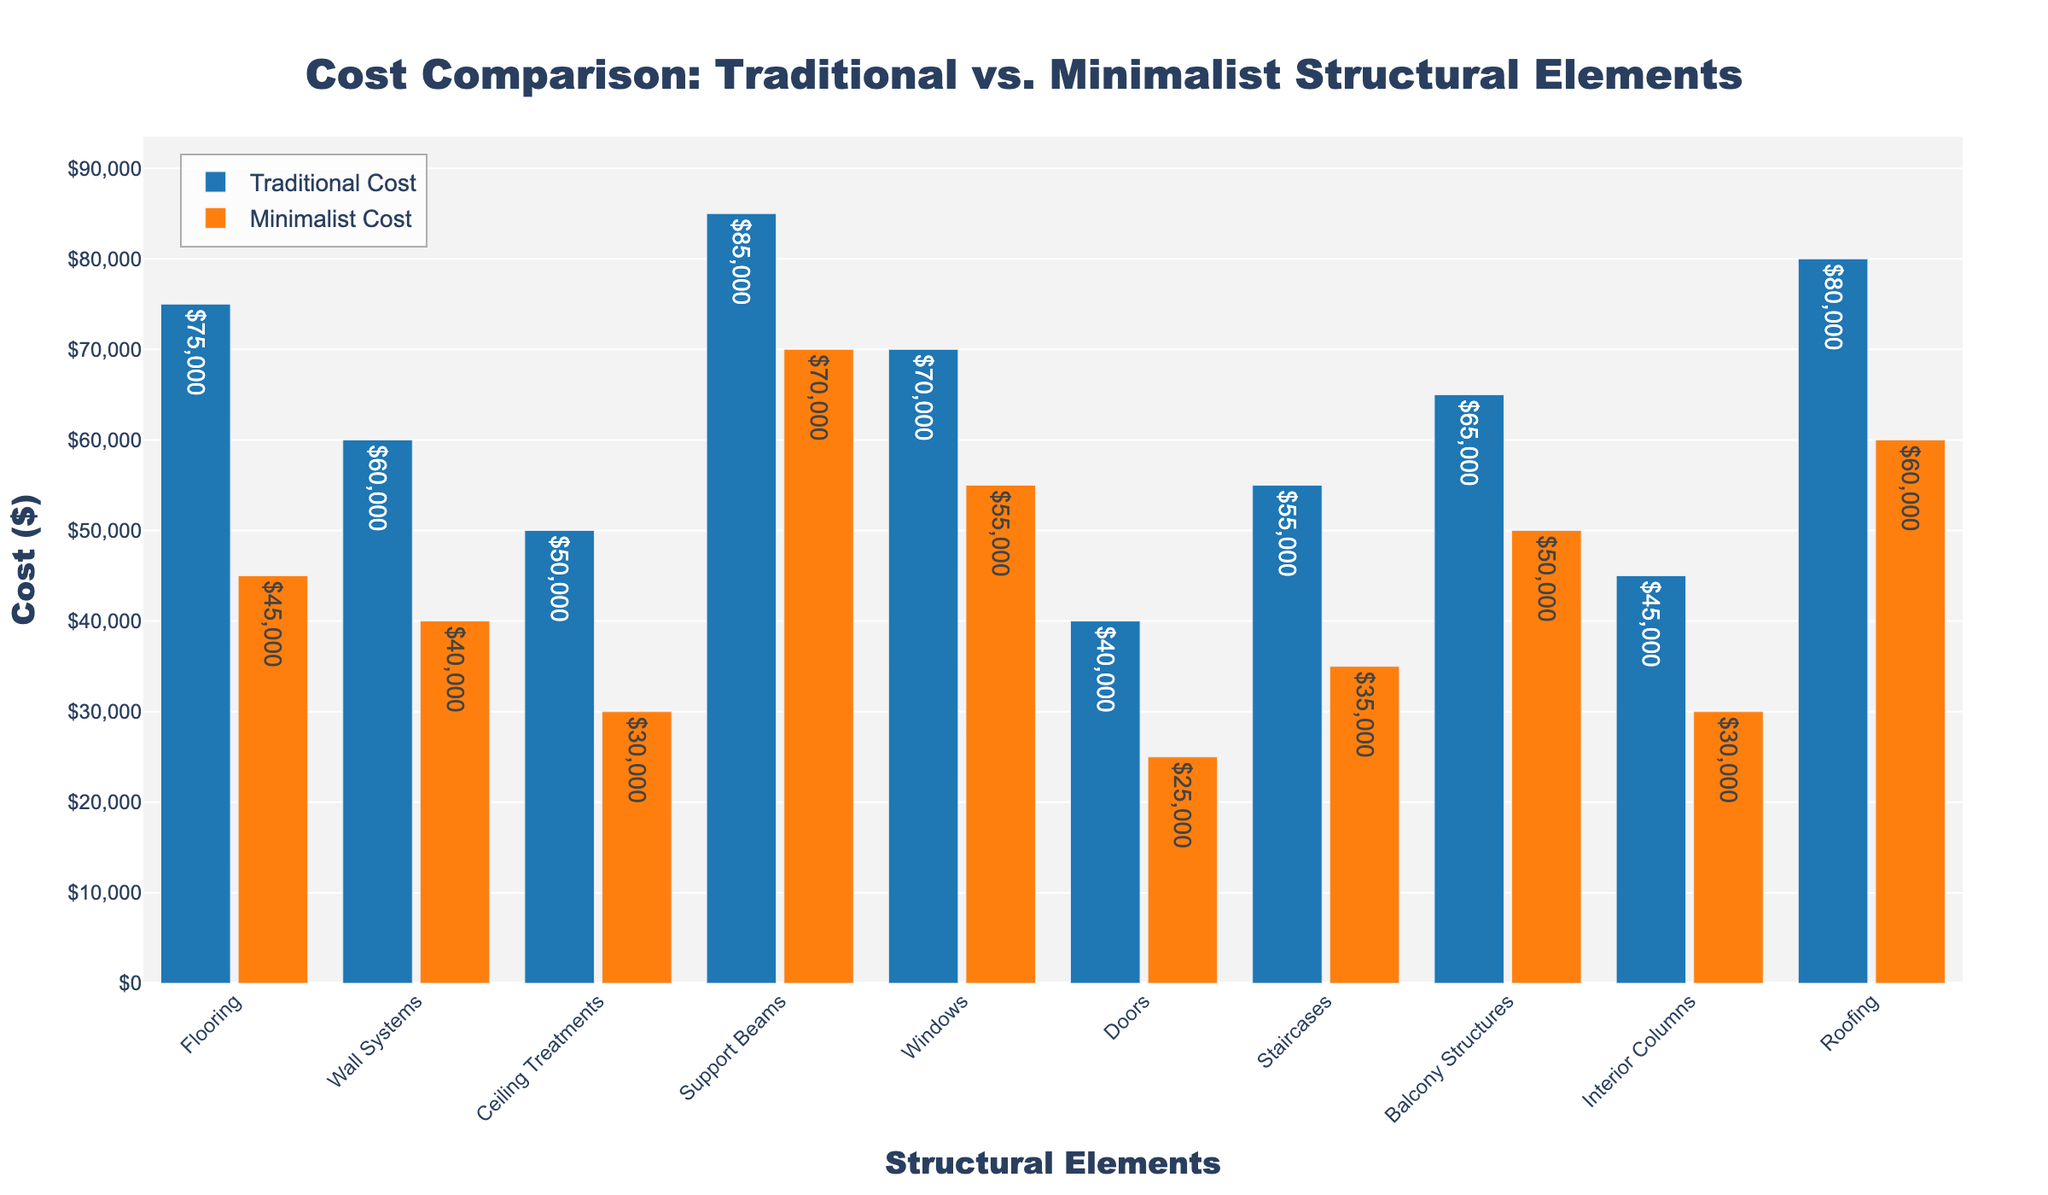Which structural element has the highest traditional cost? The element with the highest bar in the "Traditional Cost" group represents the highest traditional cost. The highest bar in this group is for "Support Beams" with a value of $85,000.
Answer: Support Beams What is the total cost difference between traditional and minimalist designs for all elements combined? First, calculate the total cost for traditional and minimalist designs separately by summing up all their costs. Subtract the total minimal cost from the total traditional cost. Total traditional cost: $75000 + $60000 + $50000 + $85000 + $70000 + $40000 + $55000 + $65000 + $45000 + $80000 = $625000. Total minimalist cost: $45000 + $40000 + $30000 + $70000 + $55000 + $25000 + $35000 + $50000 + $30000 + $60000 = $442000. The difference is $625000 - $442000 = $183000.
Answer: $183,000 Which element shows the greatest cost reduction when opting for a minimalist design? Determine the difference for each element by subtracting the minimalist cost from the traditional cost. The element with the greatest difference represents the greatest cost reduction. For example, for flooring, the difference is $75000 - $45000 = $30000. Calculating for all, the greatest reduction is for "Support Beams" with a difference of $15000.
Answer: Support Beams Which structural elements have a minimalist cost less than $40,000? Review the heights of the bars in the "Minimalist Cost" group and identify which elements are below the $40,000 mark. These elements are: "Flooring," "Wall Systems," "Ceiling Treatments," "Doors," "Staircases," and "Interior Columns."
Answer: Flooring, Wall Systems, Ceiling Treatments, Doors, Staircases, Interior Columns What is the average cost of traditional designs for all elements? Calculate the sum of all traditional design costs and divide by the number of elements. There are 10 elements. Total traditional cost: $75000 + $60000 + $50000 + $85000 + $70000 + $40000 + $55000 + $65000 + $45000 + $80000 = $625000. The average is $625000 / 10 = $62500.
Answer: $62,500 For which structural element is the difference between traditional and minimalist costs the smallest? Subtract the minimalist cost from the traditional cost for each element and identify the element with the smallest difference. For example, for flooring, the difference is $75000 - $45000 = $30000. Identifying through all, "Support Beams" has the smallest difference of $15000.
Answer: Support Beams What is the total cost of minimalist designs for ceiling treatments, doors, and windows? Sum the minimalist costs for "Ceiling Treatments," "Doors," and "Windows." For "Ceiling Treatments," the cost is $30000, for "Doors" it is $25000, and for "Windows," it is $55000. The total is $30000 + $25000 + $55000 = $110000.
Answer: $110,000 Is the minimalist cost for support beams greater than the traditional cost for staircases? Compare the minimalist cost for "Support Beams" ($70000) with the traditional cost for "Staircases" ($55000). Since $70000 is greater than $55000, the minimalist cost for Support Beams is indeed greater.
Answer: Yes Which structural element has the highest cost when comparing both traditional and minimalist designs? Identify the maximum cost between traditional and minimalist designs for each element. The highest cost is "Support Beams" (Traditional: $85,000, Minimalist: $70,000), and here the traditional cost of $85,000 is the highest overall.
Answer: Support Beams 